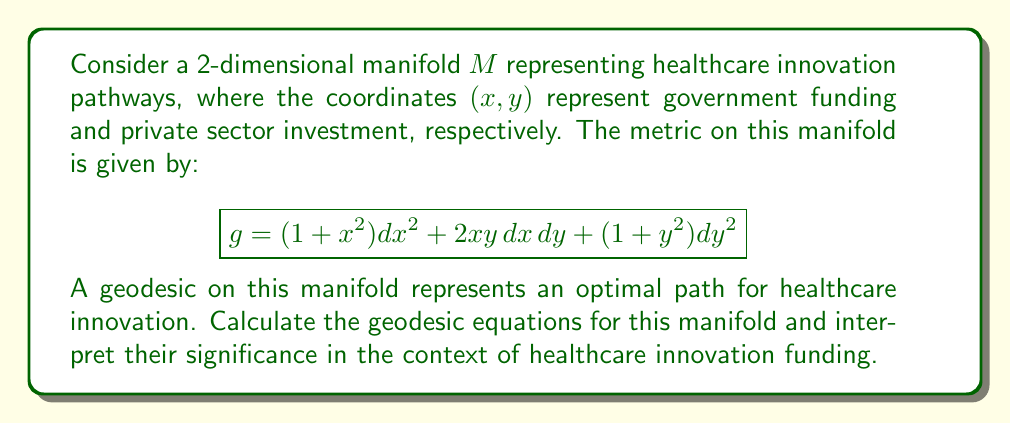Solve this math problem. To find the geodesic equations, we'll use the Euler-Lagrange equations for the energy functional:

1) First, we need to calculate the Christoffel symbols. The general formula is:

   $$\Gamma^k_{ij} = \frac{1}{2}g^{kl}(\partial_i g_{jl} + \partial_j g_{il} - \partial_l g_{ij})$$

2) The metric components are:
   $g_{11} = 1+x^2$, $g_{12} = g_{21} = xy$, $g_{22} = 1+y^2$

3) The inverse metric is:
   $$g^{-1} = \frac{1}{(1+x^2)(1+y^2)-x^2y^2} \begin{pmatrix} 1+y^2 & -xy \\ -xy & 1+x^2 \end{pmatrix}$$

4) Calculating the Christoffel symbols (we'll only show a few due to space constraints):
   $$\Gamma^1_{11} = \frac{x}{1+x^2}$$
   $$\Gamma^1_{12} = \Gamma^1_{21} = \frac{y}{2(1+x^2)}$$
   $$\Gamma^2_{11} = -\frac{xy}{1+y^2}$$

5) The geodesic equations are:
   $$\frac{d^2x^i}{dt^2} + \Gamma^i_{jk}\frac{dx^j}{dt}\frac{dx^k}{dt} = 0$$

6) Substituting the Christoffel symbols, we get:

   $$\frac{d^2x}{dt^2} + \frac{x}{1+x^2}\left(\frac{dx}{dt}\right)^2 + \frac{y}{1+x^2}\frac{dx}{dt}\frac{dy}{dt} - \frac{xy}{1+y^2}\left(\frac{dy}{dt}\right)^2 = 0$$

   $$\frac{d^2y}{dt^2} + \frac{y}{1+y^2}\left(\frac{dy}{dt}\right)^2 + \frac{x}{1+y^2}\frac{dx}{dt}\frac{dy}{dt} - \frac{xy}{1+x^2}\left(\frac{dx}{dt}\right)^2 = 0$$

Interpretation: These equations describe the optimal balance between government funding (x) and private investment (y) for healthcare innovation. The nonlinear terms suggest that the relationship between these funding sources is complex and interdependent. The presence of mixed terms (dx/dt * dy/dt) indicates that changes in one funding source affect the optimal path of the other, supporting the idea that government funding can influence private sector innovation in healthcare.
Answer: Geodesic equations:
$$\frac{d^2x}{dt^2} + \frac{x}{1+x^2}\left(\frac{dx}{dt}\right)^2 + \frac{y}{1+x^2}\frac{dx}{dt}\frac{dy}{dt} - \frac{xy}{1+y^2}\left(\frac{dy}{dt}\right)^2 = 0$$
$$\frac{d^2y}{dt^2} + \frac{y}{1+y^2}\left(\frac{dy}{dt}\right)^2 + \frac{x}{1+y^2}\frac{dx}{dt}\frac{dy}{dt} - \frac{xy}{1+x^2}\left(\frac{dx}{dt}\right)^2 = 0$$ 